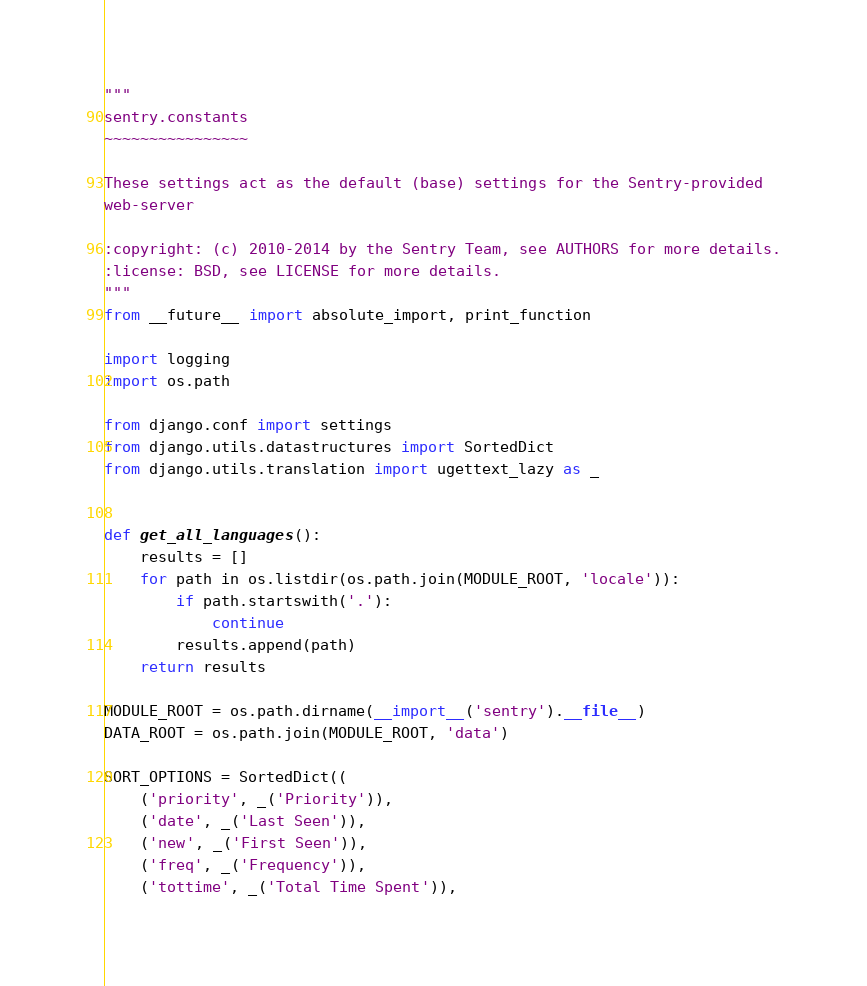<code> <loc_0><loc_0><loc_500><loc_500><_Python_>"""
sentry.constants
~~~~~~~~~~~~~~~~

These settings act as the default (base) settings for the Sentry-provided
web-server

:copyright: (c) 2010-2014 by the Sentry Team, see AUTHORS for more details.
:license: BSD, see LICENSE for more details.
"""
from __future__ import absolute_import, print_function

import logging
import os.path

from django.conf import settings
from django.utils.datastructures import SortedDict
from django.utils.translation import ugettext_lazy as _


def get_all_languages():
    results = []
    for path in os.listdir(os.path.join(MODULE_ROOT, 'locale')):
        if path.startswith('.'):
            continue
        results.append(path)
    return results

MODULE_ROOT = os.path.dirname(__import__('sentry').__file__)
DATA_ROOT = os.path.join(MODULE_ROOT, 'data')

SORT_OPTIONS = SortedDict((
    ('priority', _('Priority')),
    ('date', _('Last Seen')),
    ('new', _('First Seen')),
    ('freq', _('Frequency')),
    ('tottime', _('Total Time Spent')),</code> 